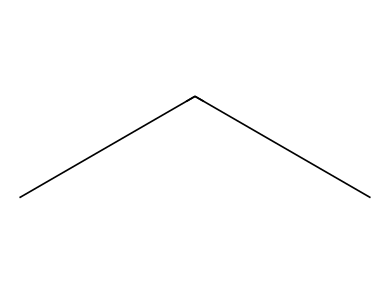What is the molecular formula of this chemical? The SMILES representation "CCC" indicates a linear arrangement of three carbon atoms bonded to each other, with sufficient hydrogen atoms filling the remaining valences, leading to a molecular formula of C3H8.
Answer: C3H8 How many carbon atoms are in this molecule? By analyzing the SMILES "CCC", we see that there are three carbon atoms connected in a straight chain.
Answer: 3 What type of chemical bond predominantly exists in this structure? The structure "CCC" indicates a carbon chain where carbon atoms are joined by single bonds, characteristic of alkanes.
Answer: single bond What is the primary use of this chemical as a refrigerant? Propane, represented by "CCC", is commonly used in refrigeration systems due to its efficiency and lower environmental impact compared to synthetic refrigerants.
Answer: refrigeration Is this refrigerant considered eco-friendly? Propane has a low global warming potential and is derived from natural sources, which qualifies it as an eco-friendly refrigerant.
Answer: eco-friendly What state is this chemical typically in at room temperature? The molecular structure "CCC" refers to propane, which is a gas at room temperature and standard pressure, making it gaseous under those conditions.
Answer: gas 